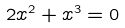Convert formula to latex. <formula><loc_0><loc_0><loc_500><loc_500>2 x ^ { 2 } + x ^ { 3 } = 0</formula> 